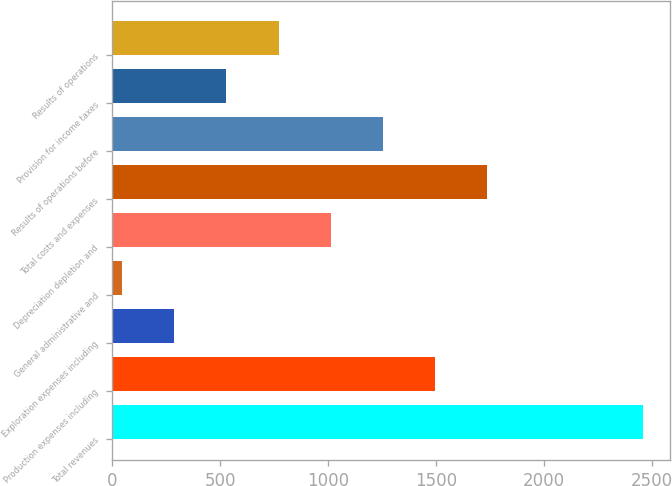<chart> <loc_0><loc_0><loc_500><loc_500><bar_chart><fcel>Total revenues<fcel>Production expenses including<fcel>Exploration expenses including<fcel>General administrative and<fcel>Depreciation depletion and<fcel>Total costs and expenses<fcel>Results of operations before<fcel>Provision for income taxes<fcel>Results of operations<nl><fcel>2460<fcel>1494.4<fcel>287.4<fcel>46<fcel>1011.6<fcel>1735.8<fcel>1253<fcel>528.8<fcel>770.2<nl></chart> 